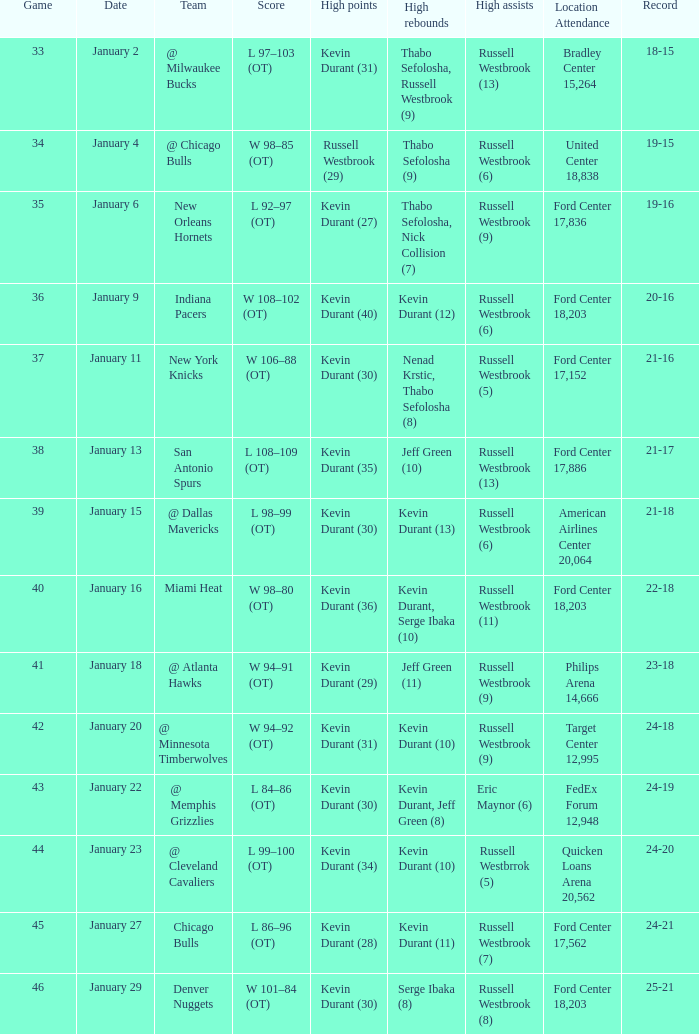Name the team for january 4 @ Chicago Bulls. 